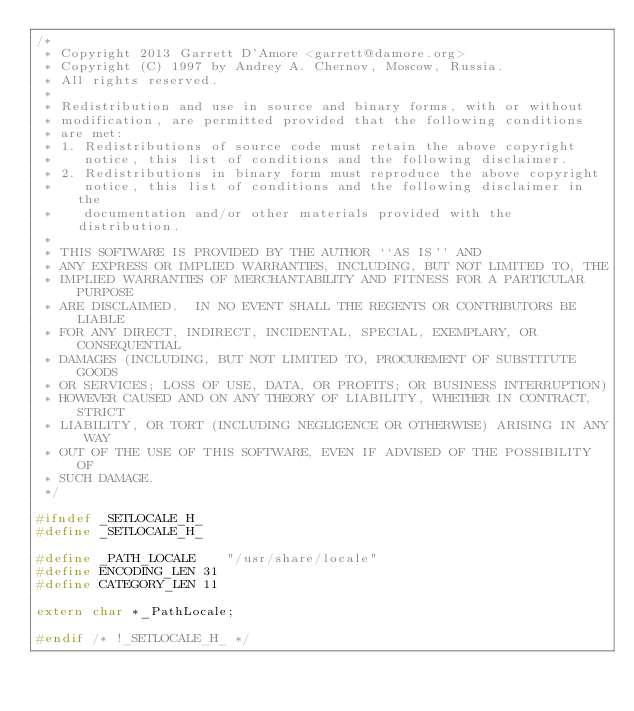Convert code to text. <code><loc_0><loc_0><loc_500><loc_500><_C_>/*
 * Copyright 2013 Garrett D'Amore <garrett@damore.org>
 * Copyright (C) 1997 by Andrey A. Chernov, Moscow, Russia.
 * All rights reserved.
 *
 * Redistribution and use in source and binary forms, with or without
 * modification, are permitted provided that the following conditions
 * are met:
 * 1. Redistributions of source code must retain the above copyright
 *    notice, this list of conditions and the following disclaimer.
 * 2. Redistributions in binary form must reproduce the above copyright
 *    notice, this list of conditions and the following disclaimer in the
 *    documentation and/or other materials provided with the distribution.
 *
 * THIS SOFTWARE IS PROVIDED BY THE AUTHOR ``AS IS'' AND
 * ANY EXPRESS OR IMPLIED WARRANTIES, INCLUDING, BUT NOT LIMITED TO, THE
 * IMPLIED WARRANTIES OF MERCHANTABILITY AND FITNESS FOR A PARTICULAR PURPOSE
 * ARE DISCLAIMED.  IN NO EVENT SHALL THE REGENTS OR CONTRIBUTORS BE LIABLE
 * FOR ANY DIRECT, INDIRECT, INCIDENTAL, SPECIAL, EXEMPLARY, OR CONSEQUENTIAL
 * DAMAGES (INCLUDING, BUT NOT LIMITED TO, PROCUREMENT OF SUBSTITUTE GOODS
 * OR SERVICES; LOSS OF USE, DATA, OR PROFITS; OR BUSINESS INTERRUPTION)
 * HOWEVER CAUSED AND ON ANY THEORY OF LIABILITY, WHETHER IN CONTRACT, STRICT
 * LIABILITY, OR TORT (INCLUDING NEGLIGENCE OR OTHERWISE) ARISING IN ANY WAY
 * OUT OF THE USE OF THIS SOFTWARE, EVEN IF ADVISED OF THE POSSIBILITY OF
 * SUCH DAMAGE.
 */

#ifndef _SETLOCALE_H_
#define	_SETLOCALE_H_

#define	_PATH_LOCALE	"/usr/share/locale"
#define	ENCODING_LEN 31
#define	CATEGORY_LEN 11

extern char *_PathLocale;

#endif /* !_SETLOCALE_H_ */
</code> 